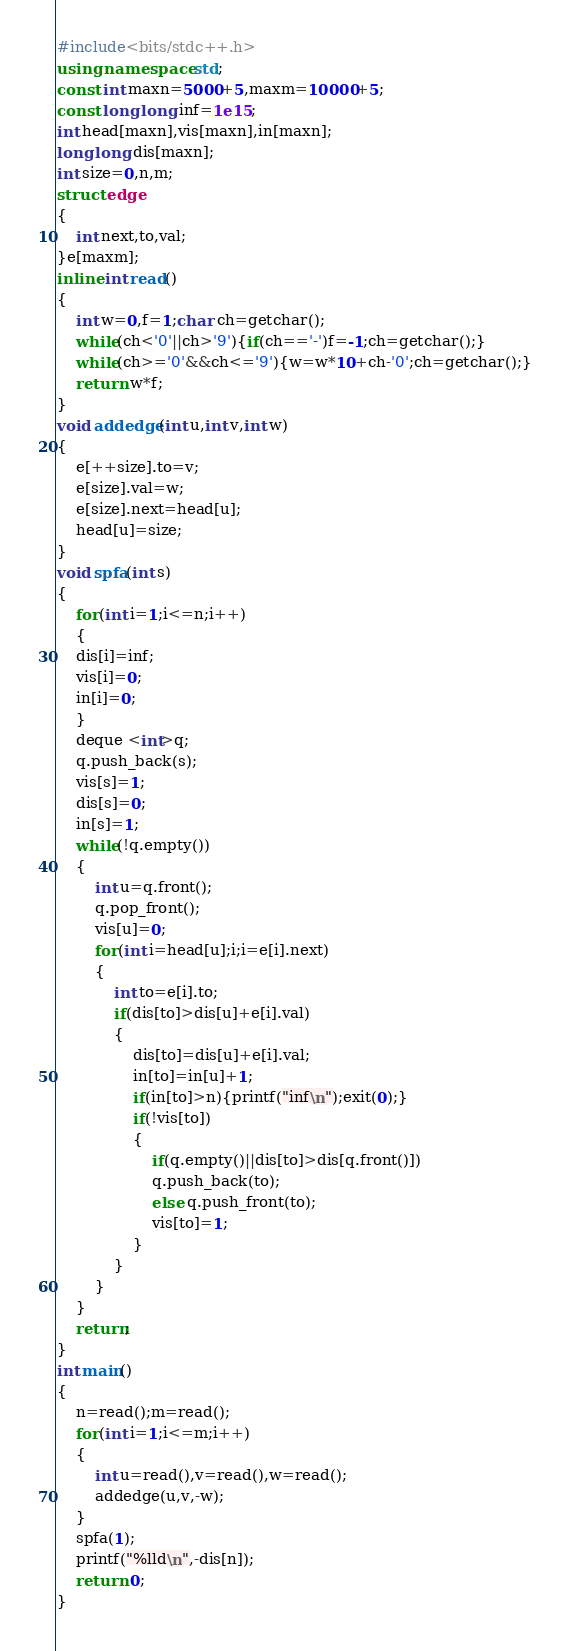Convert code to text. <code><loc_0><loc_0><loc_500><loc_500><_C++_>#include<bits/stdc++.h> 
using namespace std;
const int maxn=5000+5,maxm=10000+5;
const long long inf=1e15;
int head[maxn],vis[maxn],in[maxn];
long long dis[maxn];
int size=0,n,m;
struct edge
{
	int next,to,val;
}e[maxm];
inline int read()
{
	int w=0,f=1;char ch=getchar();
	while(ch<'0'||ch>'9'){if(ch=='-')f=-1;ch=getchar();}
	while(ch>='0'&&ch<='9'){w=w*10+ch-'0';ch=getchar();}
	return w*f;
}
void addedge(int u,int v,int w)
{
	e[++size].to=v;
	e[size].val=w;
	e[size].next=head[u];
	head[u]=size;
}
void spfa(int s)
{
	for(int i=1;i<=n;i++)
	{
	dis[i]=inf;
	vis[i]=0;
	in[i]=0;
    }
	deque <int>q;
	q.push_back(s);
	vis[s]=1;
	dis[s]=0;
	in[s]=1;
	while(!q.empty())
	{
		int u=q.front();
		q.pop_front();
		vis[u]=0;
		for(int i=head[u];i;i=e[i].next)
		{
			int to=e[i].to;
			if(dis[to]>dis[u]+e[i].val)
			{
				dis[to]=dis[u]+e[i].val;
				in[to]=in[u]+1;
				if(in[to]>n){printf("inf\n");exit(0);}
				if(!vis[to])
				{
					if(q.empty()||dis[to]>dis[q.front()])
					q.push_back(to);
					else q.push_front(to);
					vis[to]=1;
				}
			}
		}
	}
	return;
}
int main()
{
	n=read();m=read();
	for(int i=1;i<=m;i++)
	{
		int u=read(),v=read(),w=read();
		addedge(u,v,-w);
	}
	spfa(1);
	printf("%lld\n",-dis[n]);
	return 0;
}</code> 